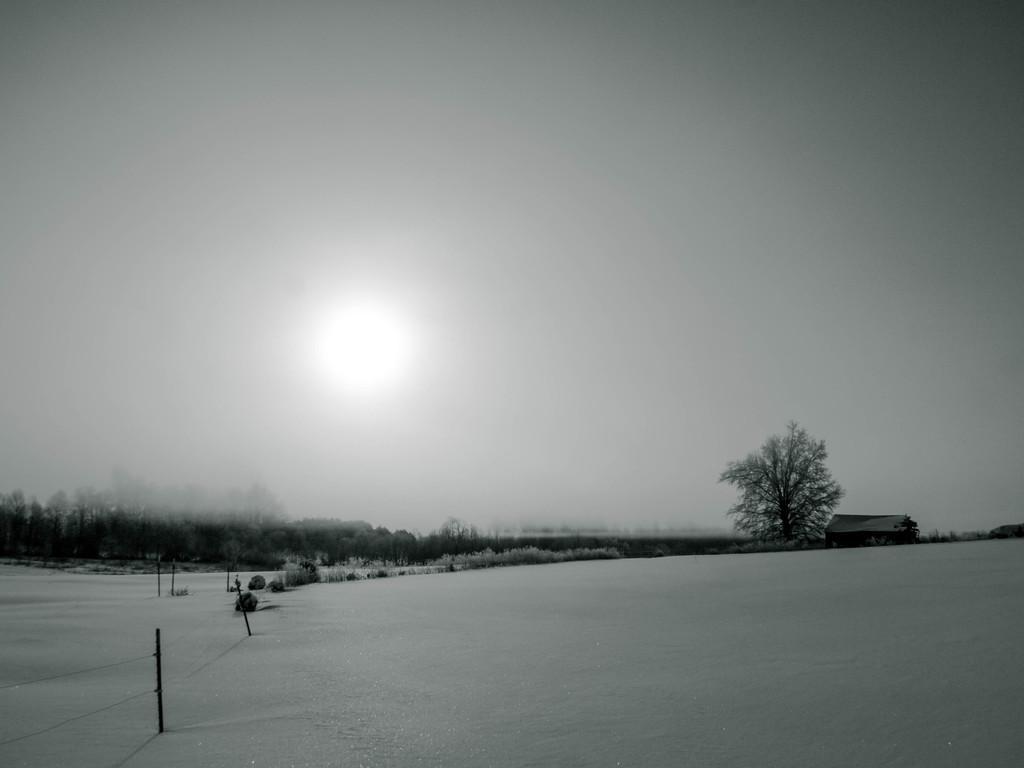Could you give a brief overview of what you see in this image? This is a black and white pic. At the bottom we can see fencing on the ground on the left side. In the background we can see trees, plants, house on the right side and sky. 